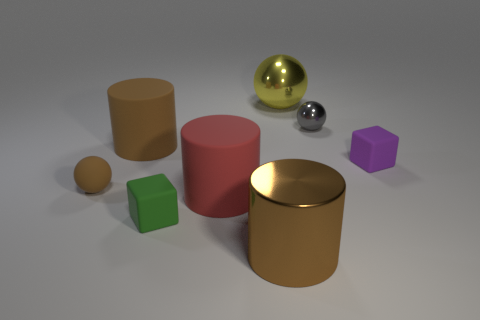How many things are small metallic cubes or cylinders?
Your answer should be very brief. 3. There is a big rubber thing in front of the small purple thing; is it the same shape as the big metallic thing that is to the left of the big yellow thing?
Your response must be concise. Yes. The big brown object behind the brown metallic cylinder has what shape?
Provide a short and direct response. Cylinder. Is the number of balls that are right of the large red thing the same as the number of objects on the right side of the tiny matte sphere?
Provide a short and direct response. No. What number of objects are big rubber cubes or small rubber things that are to the right of the small green thing?
Your response must be concise. 1. There is a tiny thing that is both in front of the gray metallic object and behind the tiny brown matte sphere; what shape is it?
Offer a terse response. Cube. The brown cylinder on the left side of the small matte cube in front of the red cylinder is made of what material?
Give a very brief answer. Rubber. Do the tiny sphere to the right of the small green thing and the tiny green cube have the same material?
Give a very brief answer. No. What is the size of the ball that is on the left side of the yellow thing?
Provide a short and direct response. Small. There is a block that is to the right of the big yellow object; are there any red objects behind it?
Your answer should be very brief. No. 